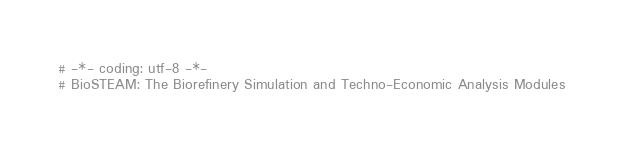Convert code to text. <code><loc_0><loc_0><loc_500><loc_500><_Python_># -*- coding: utf-8 -*-
# BioSTEAM: The Biorefinery Simulation and Techno-Economic Analysis Modules</code> 